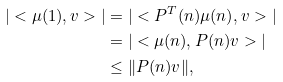Convert formula to latex. <formula><loc_0><loc_0><loc_500><loc_500>| < \mu ( 1 ) , v > | & = | < P ^ { T } ( n ) \mu ( n ) , v > | \\ & = | < \mu ( n ) , P ( n ) v > | \\ & \leq \| P ( n ) v \| ,</formula> 